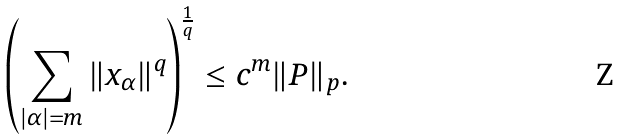Convert formula to latex. <formula><loc_0><loc_0><loc_500><loc_500>\left ( \sum _ { | \alpha | = m } \| x _ { \alpha } \| ^ { q } \right ) ^ { \frac { 1 } { q } } \leq c ^ { m } \| P \| _ { p } .</formula> 